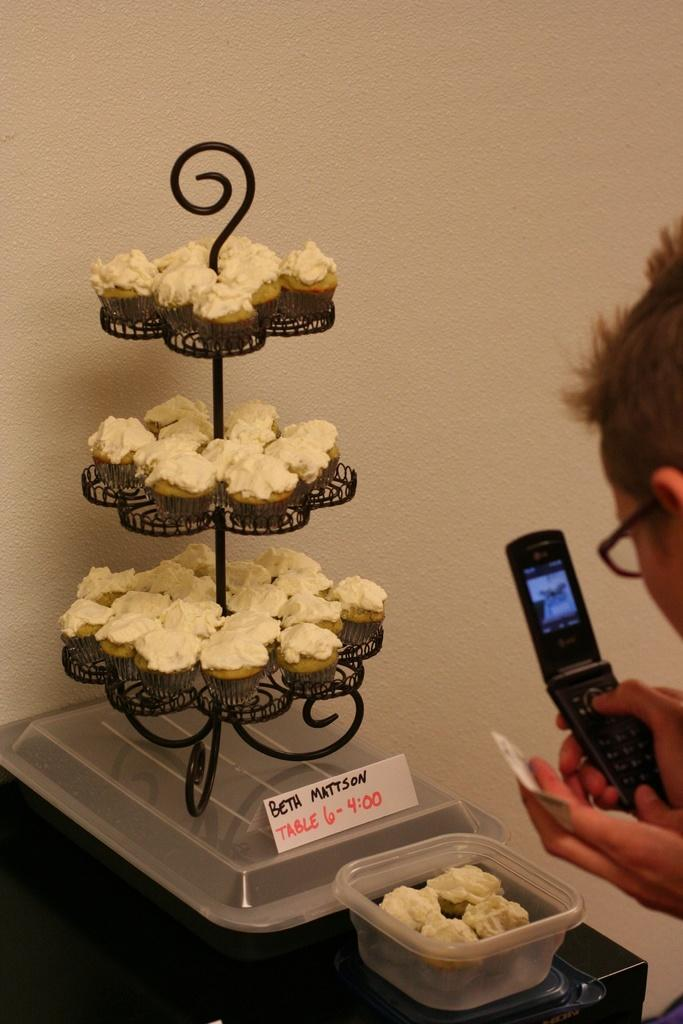What can be seen in the image? There is a person in the image. Can you describe the person's appearance? The person is wearing spectacles. What is the person holding in his hand? The person is holding a mobile in his hand. What type of food is visible in the image? There are cupcakes in the image. How are the cupcakes arranged? The cupcakes are placed in a stand. What else can be seen in the image? There is a container in the image. What advice does the person give to the patch on the wound in the image? There is no patch or wound present in the image, so it is not possible to answer that question. 